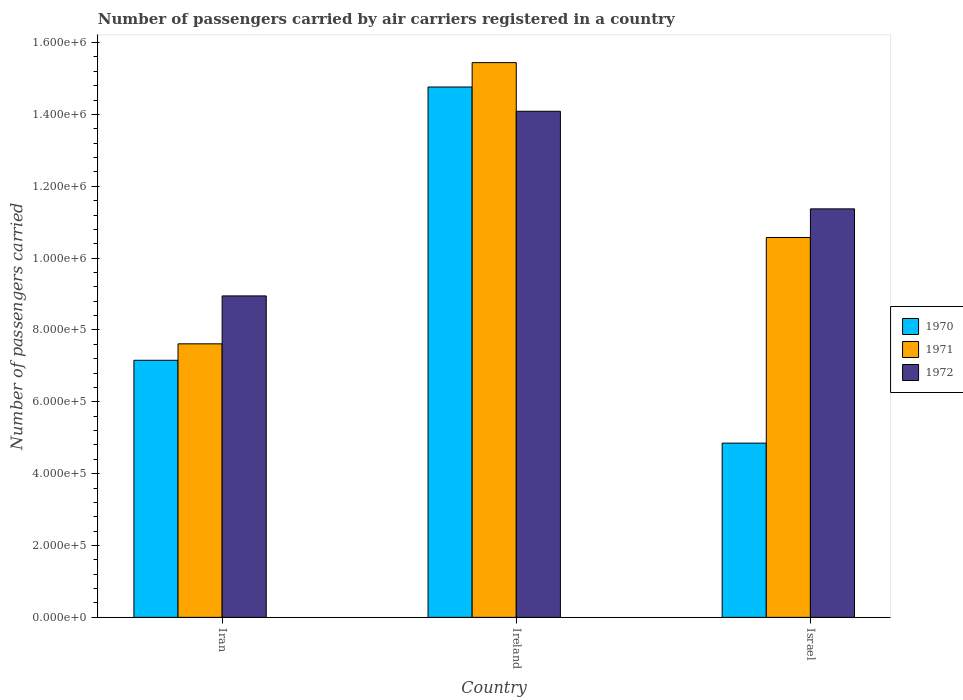How many different coloured bars are there?
Offer a terse response. 3. How many groups of bars are there?
Offer a terse response. 3. Are the number of bars per tick equal to the number of legend labels?
Offer a terse response. Yes. How many bars are there on the 1st tick from the left?
Offer a very short reply. 3. What is the label of the 2nd group of bars from the left?
Your response must be concise. Ireland. In how many cases, is the number of bars for a given country not equal to the number of legend labels?
Your answer should be very brief. 0. What is the number of passengers carried by air carriers in 1970 in Iran?
Provide a short and direct response. 7.16e+05. Across all countries, what is the maximum number of passengers carried by air carriers in 1972?
Provide a short and direct response. 1.41e+06. Across all countries, what is the minimum number of passengers carried by air carriers in 1970?
Your answer should be very brief. 4.85e+05. In which country was the number of passengers carried by air carriers in 1972 maximum?
Your response must be concise. Ireland. What is the total number of passengers carried by air carriers in 1972 in the graph?
Make the answer very short. 3.44e+06. What is the difference between the number of passengers carried by air carriers in 1971 in Iran and that in Ireland?
Provide a short and direct response. -7.83e+05. What is the difference between the number of passengers carried by air carriers in 1972 in Iran and the number of passengers carried by air carriers in 1971 in Israel?
Offer a terse response. -1.63e+05. What is the average number of passengers carried by air carriers in 1970 per country?
Provide a succinct answer. 8.92e+05. What is the difference between the number of passengers carried by air carriers of/in 1971 and number of passengers carried by air carriers of/in 1972 in Israel?
Your response must be concise. -7.97e+04. What is the ratio of the number of passengers carried by air carriers in 1970 in Iran to that in Israel?
Give a very brief answer. 1.48. Is the difference between the number of passengers carried by air carriers in 1971 in Ireland and Israel greater than the difference between the number of passengers carried by air carriers in 1972 in Ireland and Israel?
Keep it short and to the point. Yes. What is the difference between the highest and the second highest number of passengers carried by air carriers in 1972?
Provide a succinct answer. 5.14e+05. What is the difference between the highest and the lowest number of passengers carried by air carriers in 1972?
Your answer should be very brief. 5.14e+05. What does the 1st bar from the left in Iran represents?
Your answer should be compact. 1970. What does the 2nd bar from the right in Israel represents?
Offer a very short reply. 1971. Is it the case that in every country, the sum of the number of passengers carried by air carriers in 1970 and number of passengers carried by air carriers in 1971 is greater than the number of passengers carried by air carriers in 1972?
Give a very brief answer. Yes. Are all the bars in the graph horizontal?
Make the answer very short. No. What is the difference between two consecutive major ticks on the Y-axis?
Give a very brief answer. 2.00e+05. Does the graph contain grids?
Offer a very short reply. No. Where does the legend appear in the graph?
Give a very brief answer. Center right. How many legend labels are there?
Give a very brief answer. 3. What is the title of the graph?
Offer a terse response. Number of passengers carried by air carriers registered in a country. Does "1961" appear as one of the legend labels in the graph?
Keep it short and to the point. No. What is the label or title of the Y-axis?
Offer a very short reply. Number of passengers carried. What is the Number of passengers carried in 1970 in Iran?
Provide a succinct answer. 7.16e+05. What is the Number of passengers carried of 1971 in Iran?
Offer a very short reply. 7.61e+05. What is the Number of passengers carried in 1972 in Iran?
Your answer should be compact. 8.95e+05. What is the Number of passengers carried in 1970 in Ireland?
Make the answer very short. 1.48e+06. What is the Number of passengers carried of 1971 in Ireland?
Your answer should be compact. 1.54e+06. What is the Number of passengers carried of 1972 in Ireland?
Offer a terse response. 1.41e+06. What is the Number of passengers carried in 1970 in Israel?
Provide a succinct answer. 4.85e+05. What is the Number of passengers carried of 1971 in Israel?
Provide a succinct answer. 1.06e+06. What is the Number of passengers carried in 1972 in Israel?
Ensure brevity in your answer.  1.14e+06. Across all countries, what is the maximum Number of passengers carried of 1970?
Your answer should be very brief. 1.48e+06. Across all countries, what is the maximum Number of passengers carried in 1971?
Offer a very short reply. 1.54e+06. Across all countries, what is the maximum Number of passengers carried of 1972?
Your answer should be compact. 1.41e+06. Across all countries, what is the minimum Number of passengers carried of 1970?
Your answer should be compact. 4.85e+05. Across all countries, what is the minimum Number of passengers carried of 1971?
Give a very brief answer. 7.61e+05. Across all countries, what is the minimum Number of passengers carried in 1972?
Provide a succinct answer. 8.95e+05. What is the total Number of passengers carried of 1970 in the graph?
Provide a short and direct response. 2.68e+06. What is the total Number of passengers carried in 1971 in the graph?
Make the answer very short. 3.36e+06. What is the total Number of passengers carried in 1972 in the graph?
Provide a short and direct response. 3.44e+06. What is the difference between the Number of passengers carried of 1970 in Iran and that in Ireland?
Ensure brevity in your answer.  -7.61e+05. What is the difference between the Number of passengers carried in 1971 in Iran and that in Ireland?
Your answer should be compact. -7.83e+05. What is the difference between the Number of passengers carried in 1972 in Iran and that in Ireland?
Keep it short and to the point. -5.14e+05. What is the difference between the Number of passengers carried in 1970 in Iran and that in Israel?
Keep it short and to the point. 2.31e+05. What is the difference between the Number of passengers carried of 1971 in Iran and that in Israel?
Your response must be concise. -2.96e+05. What is the difference between the Number of passengers carried in 1972 in Iran and that in Israel?
Provide a succinct answer. -2.42e+05. What is the difference between the Number of passengers carried of 1970 in Ireland and that in Israel?
Ensure brevity in your answer.  9.91e+05. What is the difference between the Number of passengers carried in 1971 in Ireland and that in Israel?
Your answer should be very brief. 4.87e+05. What is the difference between the Number of passengers carried of 1972 in Ireland and that in Israel?
Provide a succinct answer. 2.72e+05. What is the difference between the Number of passengers carried in 1970 in Iran and the Number of passengers carried in 1971 in Ireland?
Provide a succinct answer. -8.29e+05. What is the difference between the Number of passengers carried of 1970 in Iran and the Number of passengers carried of 1972 in Ireland?
Your answer should be compact. -6.93e+05. What is the difference between the Number of passengers carried of 1971 in Iran and the Number of passengers carried of 1972 in Ireland?
Give a very brief answer. -6.47e+05. What is the difference between the Number of passengers carried in 1970 in Iran and the Number of passengers carried in 1971 in Israel?
Make the answer very short. -3.42e+05. What is the difference between the Number of passengers carried in 1970 in Iran and the Number of passengers carried in 1972 in Israel?
Your answer should be compact. -4.22e+05. What is the difference between the Number of passengers carried in 1971 in Iran and the Number of passengers carried in 1972 in Israel?
Offer a terse response. -3.76e+05. What is the difference between the Number of passengers carried of 1970 in Ireland and the Number of passengers carried of 1971 in Israel?
Provide a short and direct response. 4.19e+05. What is the difference between the Number of passengers carried of 1970 in Ireland and the Number of passengers carried of 1972 in Israel?
Ensure brevity in your answer.  3.39e+05. What is the difference between the Number of passengers carried of 1971 in Ireland and the Number of passengers carried of 1972 in Israel?
Your answer should be very brief. 4.07e+05. What is the average Number of passengers carried in 1970 per country?
Keep it short and to the point. 8.92e+05. What is the average Number of passengers carried in 1971 per country?
Offer a terse response. 1.12e+06. What is the average Number of passengers carried of 1972 per country?
Make the answer very short. 1.15e+06. What is the difference between the Number of passengers carried in 1970 and Number of passengers carried in 1971 in Iran?
Offer a terse response. -4.58e+04. What is the difference between the Number of passengers carried in 1970 and Number of passengers carried in 1972 in Iran?
Provide a succinct answer. -1.79e+05. What is the difference between the Number of passengers carried in 1971 and Number of passengers carried in 1972 in Iran?
Offer a terse response. -1.33e+05. What is the difference between the Number of passengers carried in 1970 and Number of passengers carried in 1971 in Ireland?
Keep it short and to the point. -6.79e+04. What is the difference between the Number of passengers carried of 1970 and Number of passengers carried of 1972 in Ireland?
Your answer should be very brief. 6.75e+04. What is the difference between the Number of passengers carried of 1971 and Number of passengers carried of 1972 in Ireland?
Keep it short and to the point. 1.35e+05. What is the difference between the Number of passengers carried in 1970 and Number of passengers carried in 1971 in Israel?
Your answer should be very brief. -5.72e+05. What is the difference between the Number of passengers carried in 1970 and Number of passengers carried in 1972 in Israel?
Keep it short and to the point. -6.52e+05. What is the difference between the Number of passengers carried in 1971 and Number of passengers carried in 1972 in Israel?
Your answer should be compact. -7.97e+04. What is the ratio of the Number of passengers carried in 1970 in Iran to that in Ireland?
Offer a very short reply. 0.48. What is the ratio of the Number of passengers carried of 1971 in Iran to that in Ireland?
Keep it short and to the point. 0.49. What is the ratio of the Number of passengers carried in 1972 in Iran to that in Ireland?
Ensure brevity in your answer.  0.64. What is the ratio of the Number of passengers carried of 1970 in Iran to that in Israel?
Keep it short and to the point. 1.48. What is the ratio of the Number of passengers carried in 1971 in Iran to that in Israel?
Keep it short and to the point. 0.72. What is the ratio of the Number of passengers carried in 1972 in Iran to that in Israel?
Your answer should be very brief. 0.79. What is the ratio of the Number of passengers carried of 1970 in Ireland to that in Israel?
Offer a very short reply. 3.04. What is the ratio of the Number of passengers carried in 1971 in Ireland to that in Israel?
Ensure brevity in your answer.  1.46. What is the ratio of the Number of passengers carried of 1972 in Ireland to that in Israel?
Your answer should be very brief. 1.24. What is the difference between the highest and the second highest Number of passengers carried in 1970?
Your response must be concise. 7.61e+05. What is the difference between the highest and the second highest Number of passengers carried of 1971?
Offer a very short reply. 4.87e+05. What is the difference between the highest and the second highest Number of passengers carried of 1972?
Keep it short and to the point. 2.72e+05. What is the difference between the highest and the lowest Number of passengers carried of 1970?
Your response must be concise. 9.91e+05. What is the difference between the highest and the lowest Number of passengers carried in 1971?
Your answer should be compact. 7.83e+05. What is the difference between the highest and the lowest Number of passengers carried of 1972?
Your response must be concise. 5.14e+05. 